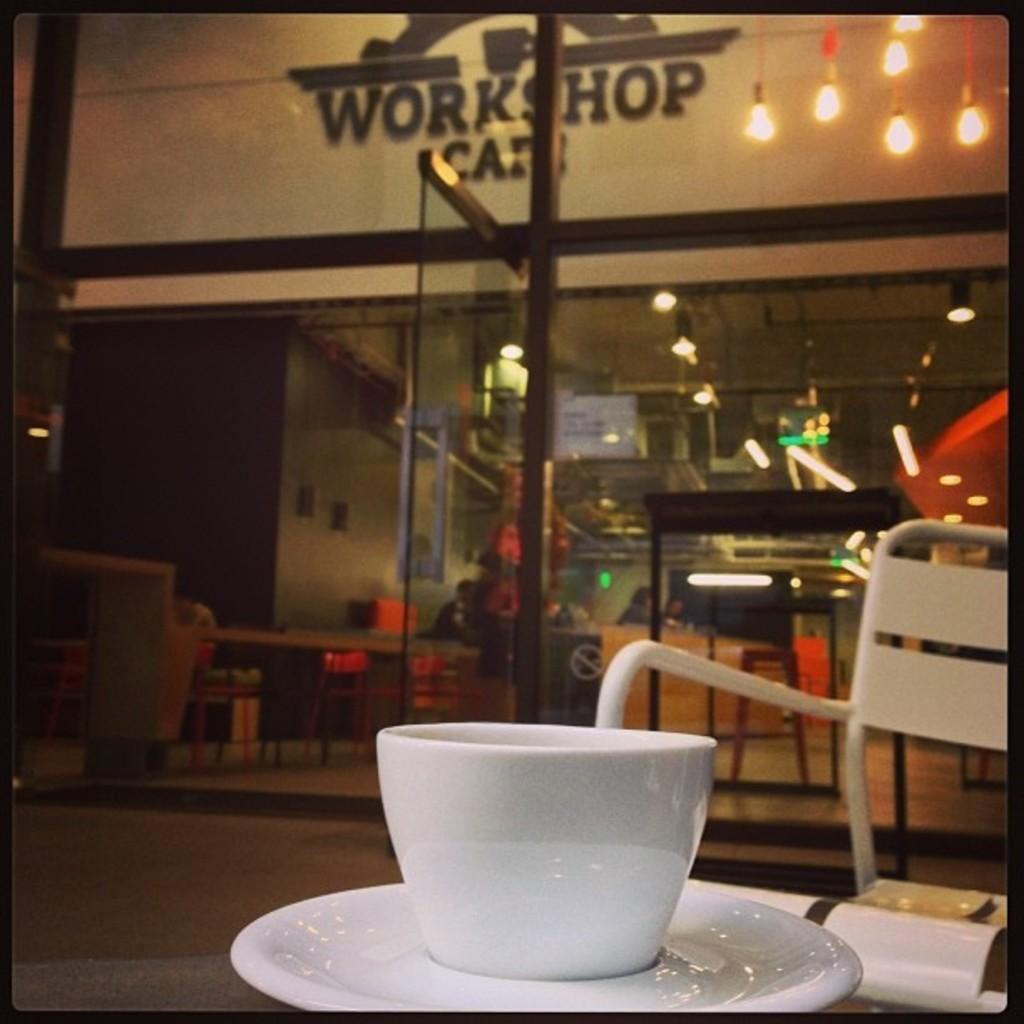<image>
Summarize the visual content of the image. a white cup next to a store that says workshop 